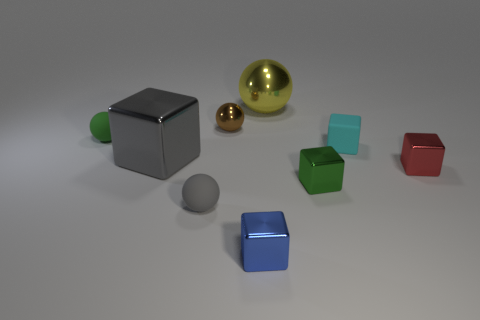Are there any small rubber objects of the same color as the large cube?
Your response must be concise. Yes. There is a thing that is the same color as the big cube; what shape is it?
Give a very brief answer. Sphere. How many other things are there of the same size as the green matte ball?
Provide a short and direct response. 6. How many other things are there of the same shape as the small cyan matte thing?
Offer a terse response. 4. There is a green object on the right side of the large gray block; is its shape the same as the gray object that is behind the tiny red cube?
Ensure brevity in your answer.  Yes. What number of objects are either tiny metal cubes or gray spheres?
Keep it short and to the point. 4. Are any small cyan objects visible?
Ensure brevity in your answer.  Yes. Do the big object behind the cyan rubber cube and the large cube have the same material?
Offer a terse response. Yes. Is there a gray object that has the same shape as the cyan matte object?
Provide a short and direct response. Yes. Is the number of tiny cyan matte blocks that are to the left of the brown metallic object the same as the number of large yellow rubber spheres?
Ensure brevity in your answer.  Yes. 